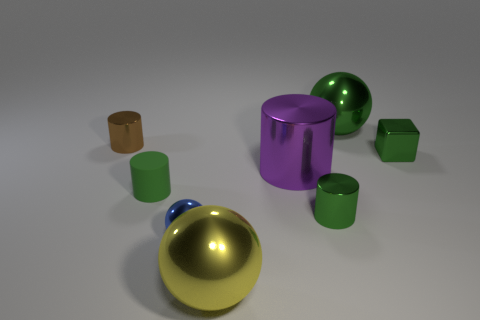Is the shape of the small green rubber thing the same as the green thing behind the tiny brown cylinder?
Provide a short and direct response. No. The tiny shiny object that is the same color as the tiny block is what shape?
Offer a terse response. Cylinder. Is the number of brown metal objects that are on the right side of the tiny brown shiny cylinder less than the number of tiny blocks?
Make the answer very short. Yes. Is the shape of the large purple metal thing the same as the blue thing?
Offer a terse response. No. The green cylinder that is made of the same material as the large yellow ball is what size?
Provide a succinct answer. Small. Is the number of cubes less than the number of gray spheres?
Offer a terse response. No. What number of tiny things are either green rubber cylinders or brown shiny cylinders?
Keep it short and to the point. 2. What number of metallic objects are both in front of the brown cylinder and behind the tiny brown cylinder?
Provide a short and direct response. 0. Is the number of small yellow matte balls greater than the number of large cylinders?
Your response must be concise. No. What number of other objects are the same shape as the tiny green matte thing?
Ensure brevity in your answer.  3. 